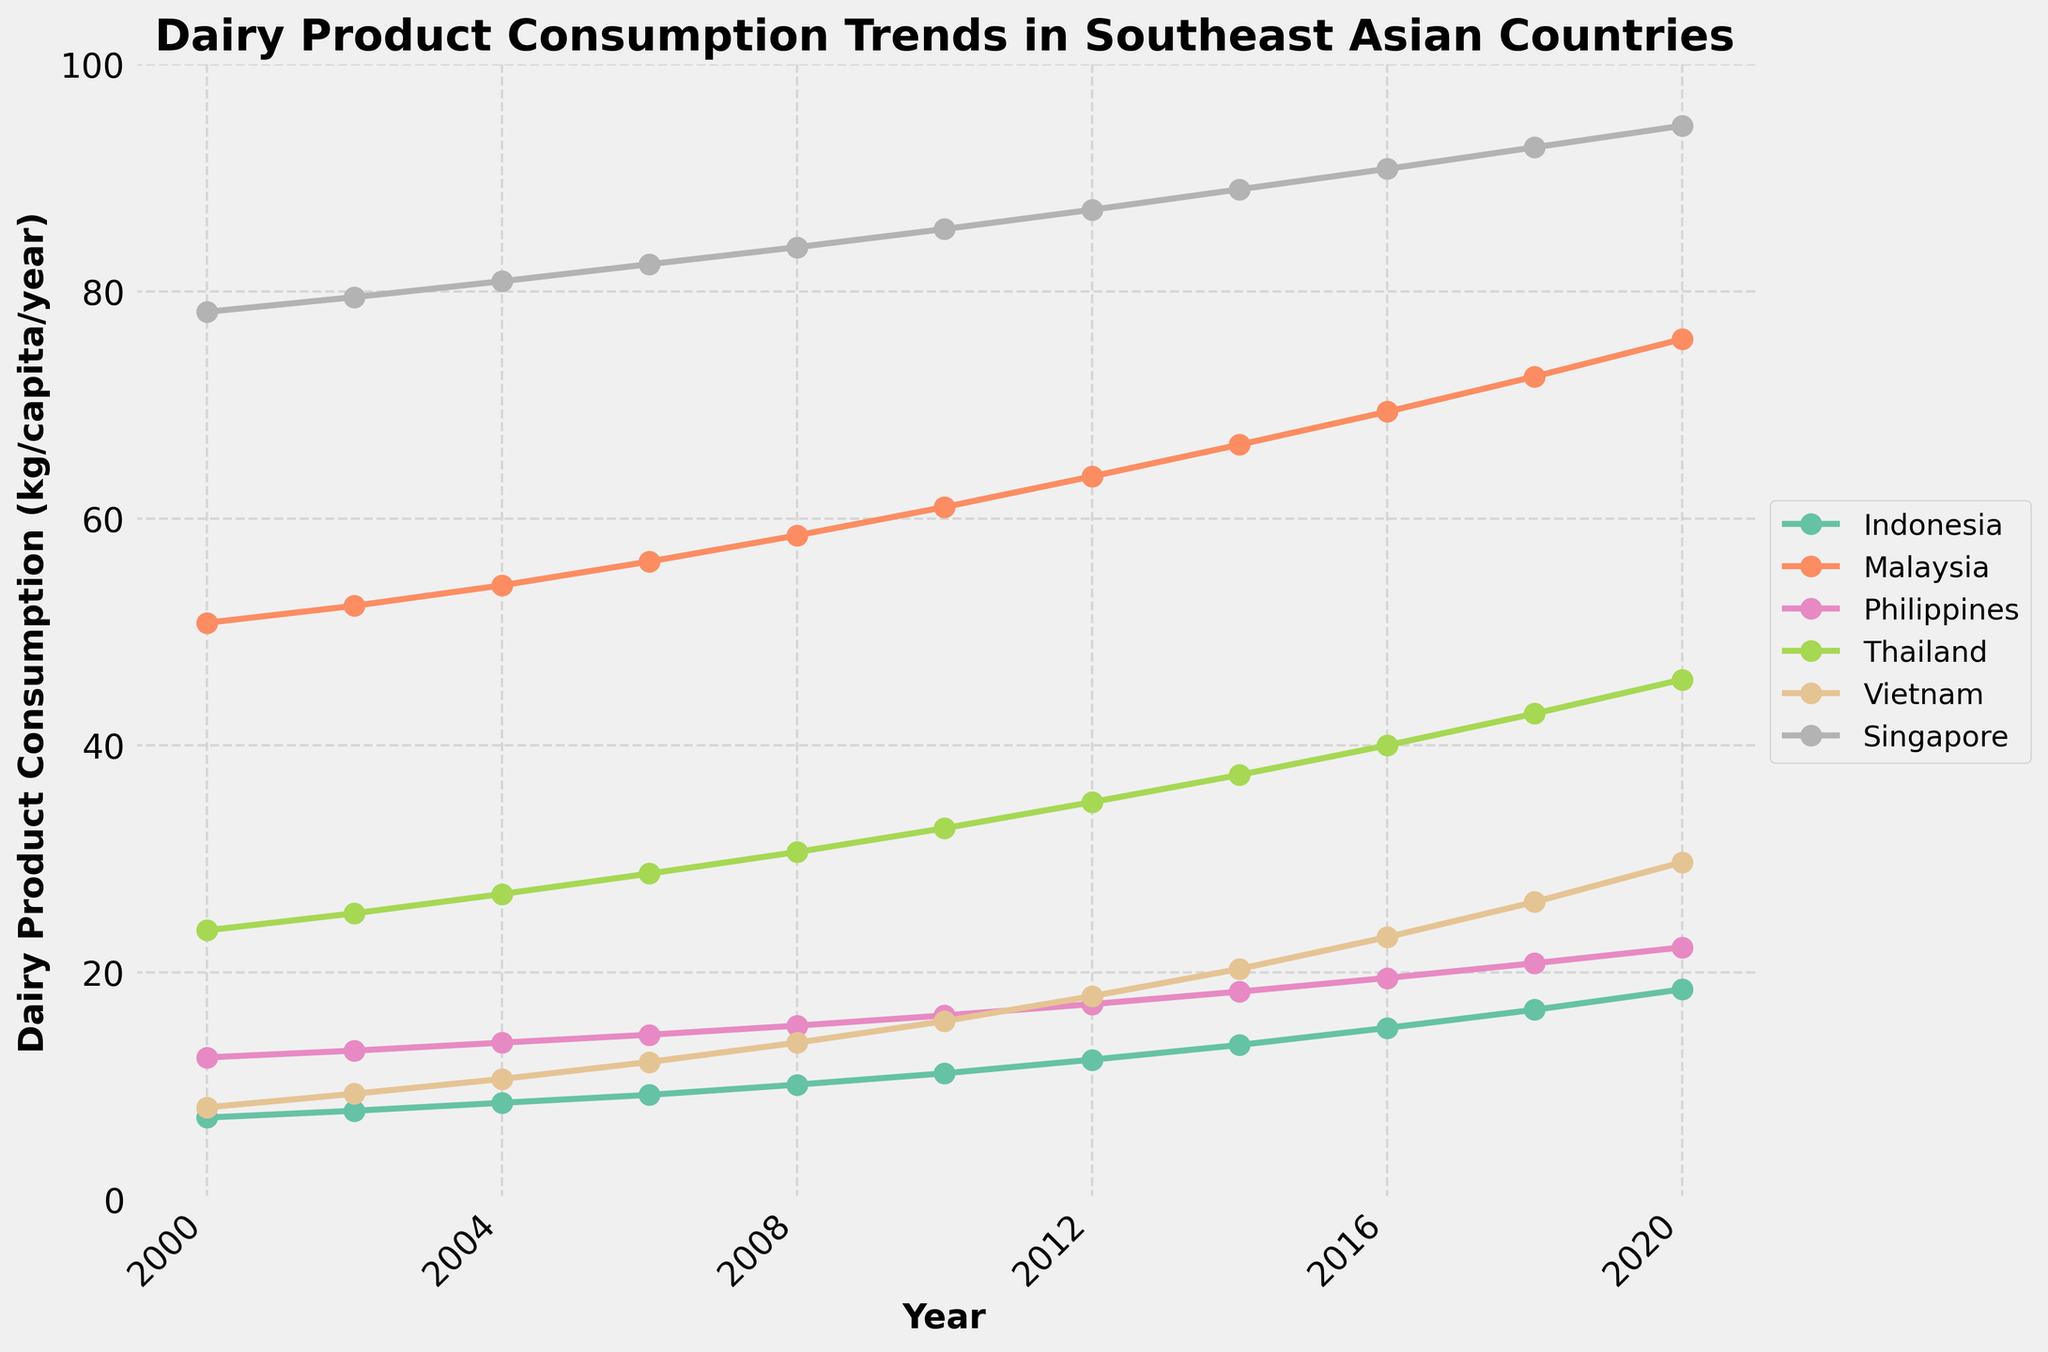Which country had the highest dairy product consumption in 2020? Look at the endpoints of each line corresponding to the year 2020 and identify the highest value among the countries. Singapore has the highest value around 94.6 kg/capita/year.
Answer: Singapore How did dairy product consumption in Vietnam change from 2000 to 2020? Subtract the consumption value of Vietnam in 2000 from the value in 2020 (29.7 - 8.1).
Answer: Increased by 21.6 kg/capita/year Which country showed the most consistent growth in dairy product consumption over the 20 years? Look for the country whose line has a smooth, steadily increasing trend with no large fluctuations. Malaysia shows a consistent upward trend without significant fluctuations.
Answer: Malaysia In which year did Indonesia's dairy product consumption surpass 15 kg/capita/year? Find the year on Indonesia's line where the value first exceeds 15 kg/capita/year, which occurs around 2016.
Answer: 2016 Compare the dairy product consumption trend of the Philippines and Thailand. Which country had a higher increase from 2000 to 2020? Calculate the difference between the 2020 and 2000 values for both countries: Philippines (22.2 - 12.5) = 9.7 kg/capita/year, Thailand (45.8 - 23.7) = 22.1 kg/capita/year. Thailand had a higher increase.
Answer: Thailand Is there any country whose dairy product consumption never decreased over the years? Check all the countries' lines for any downturns. If there's no decrease, it means the consumption never went down. All countries show a steady increase, none decrease.
Answer: No Which country had the smallest growth in dairy product consumption from 2000 to 2020? Calculate the difference between the 2020 and 2000 values for all countries and find the smallest difference. Indonesia (18.5 - 7.2) = 11.3 kg/capita/year has the smallest growth.
Answer: Indonesia At what approximate rate did Singapore's dairy product consumption increase per year between 2000 and 2020? Calculate the difference between the 2020 and 2000 consumption values for Singapore and divide by the number of years (94.6 - 78.2) / 20.
Answer: 0.82 kg/capita/year Which country had a sharper increase in dairy consumption between 2018 and 2020, Vietnam or the Philippines? Calculate the difference between the 2020 and 2018 values for both countries and compare: Vietnam (29.7 - 26.2) = 3.5 kg/capita/year, Philippines (22.2 - 20.8) = 1.4 kg/capita/year. Vietnam had a sharper increase.
Answer: Vietnam 